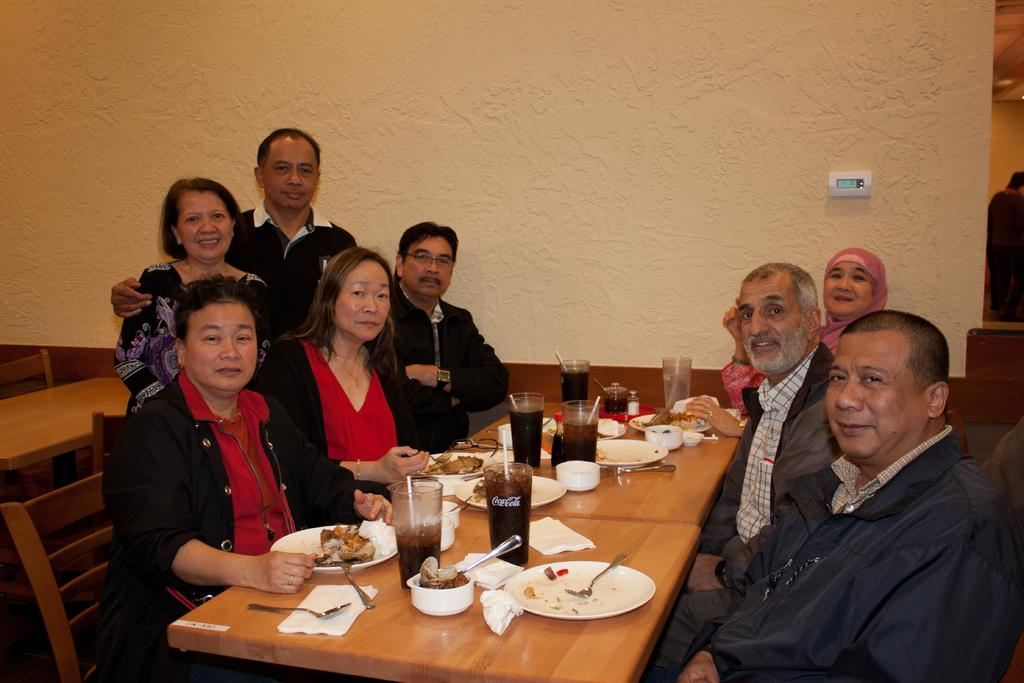How many people are in the image? There are several people in the image. What are the people doing in the image? The people are sitting at a table. What is the color of the table? The table is brown. What else can be seen on the table besides the people? There are food items on the table. What type of brain is visible on the table in the image? There is no brain present in the image; only people, a brown table, and food items are visible. 